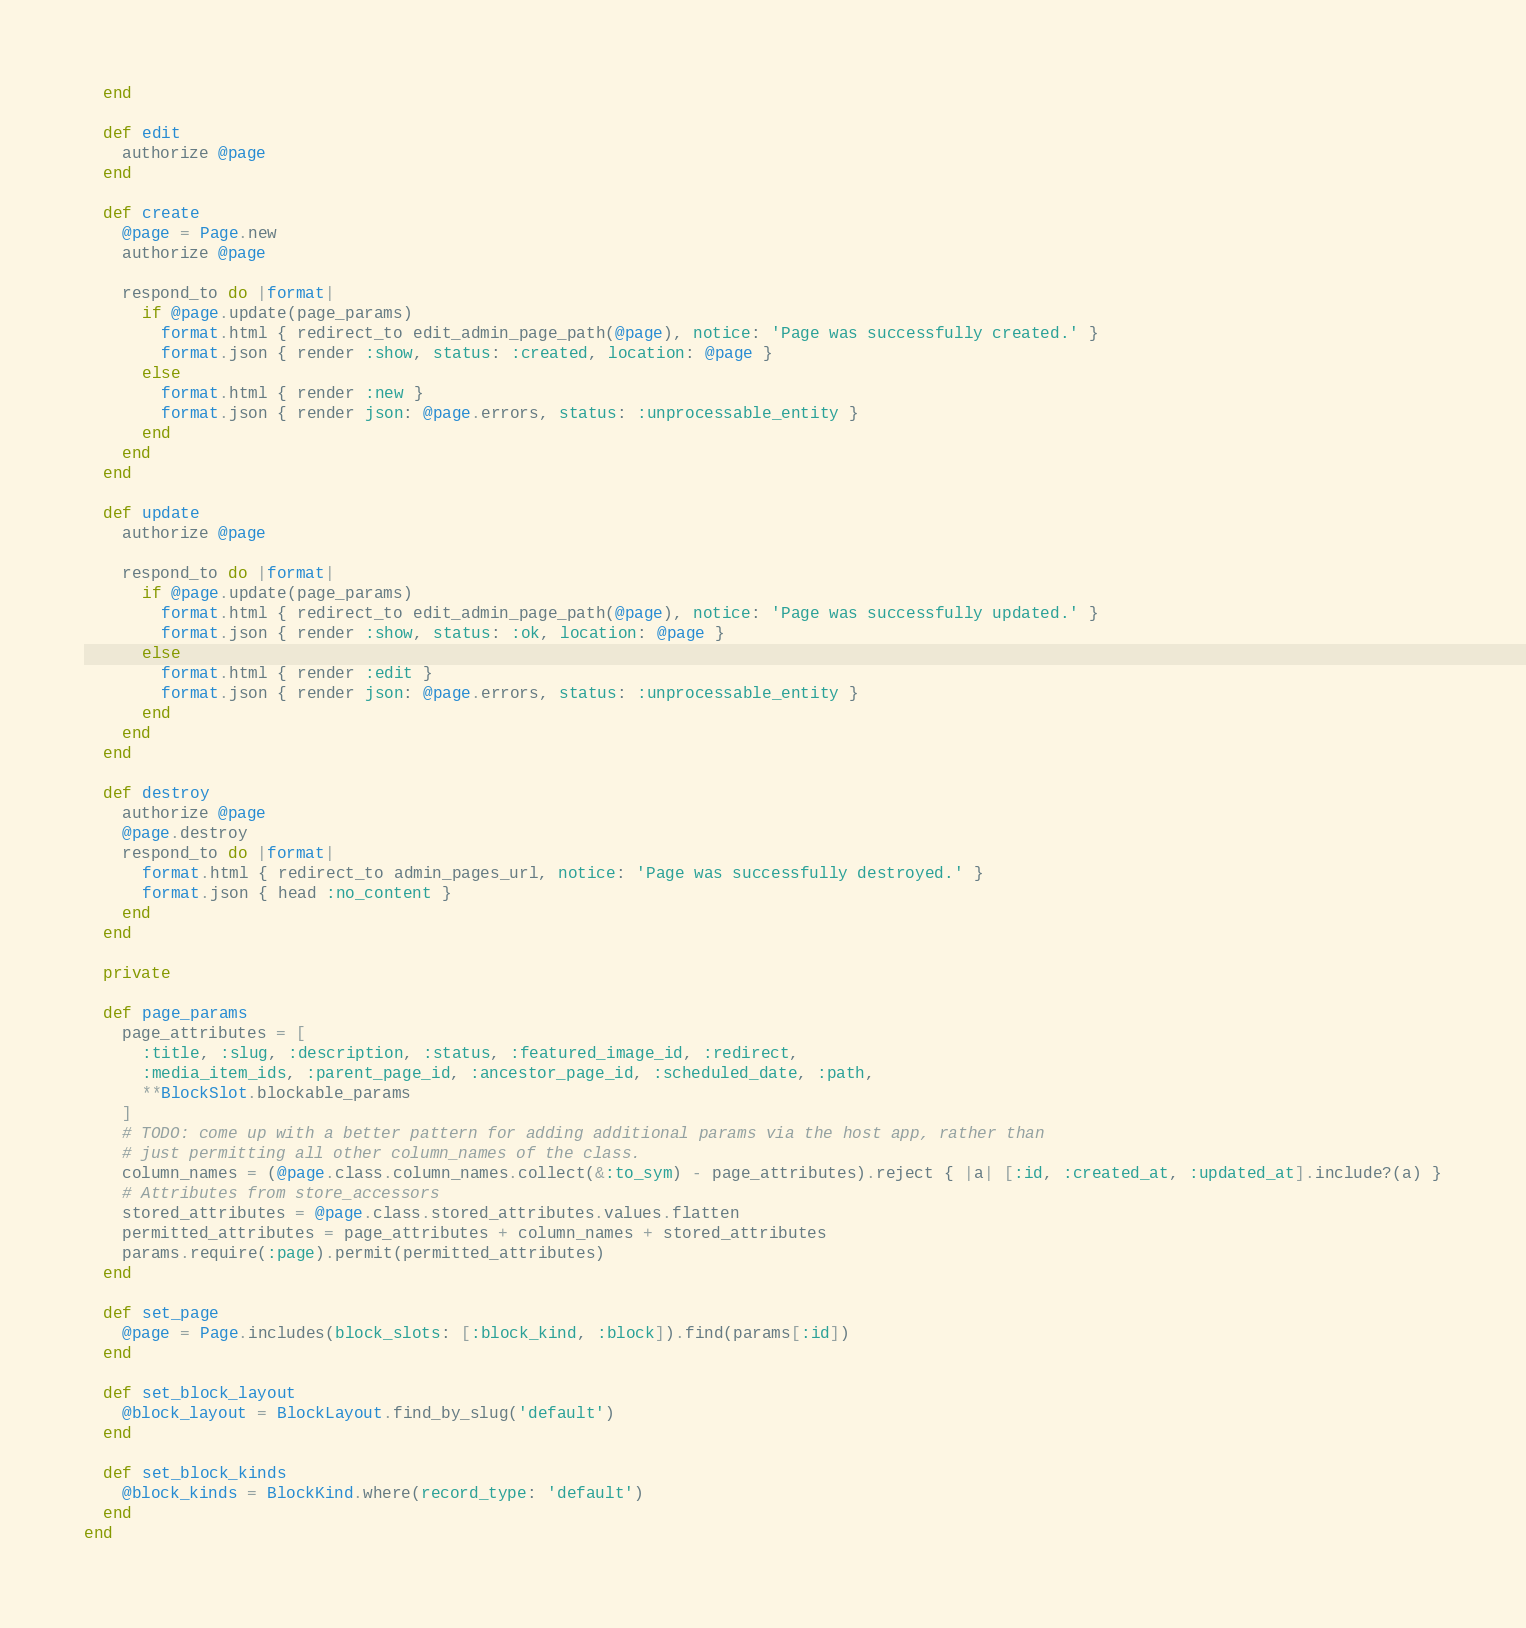<code> <loc_0><loc_0><loc_500><loc_500><_Ruby_>  end

  def edit
    authorize @page
  end

  def create
    @page = Page.new
    authorize @page

    respond_to do |format|
      if @page.update(page_params)
        format.html { redirect_to edit_admin_page_path(@page), notice: 'Page was successfully created.' }
        format.json { render :show, status: :created, location: @page }
      else
        format.html { render :new }
        format.json { render json: @page.errors, status: :unprocessable_entity }
      end
    end
  end

  def update
    authorize @page

    respond_to do |format|
      if @page.update(page_params)
        format.html { redirect_to edit_admin_page_path(@page), notice: 'Page was successfully updated.' }
        format.json { render :show, status: :ok, location: @page }
      else
        format.html { render :edit }
        format.json { render json: @page.errors, status: :unprocessable_entity }
      end
    end
  end

  def destroy
    authorize @page
    @page.destroy
    respond_to do |format|
      format.html { redirect_to admin_pages_url, notice: 'Page was successfully destroyed.' }
      format.json { head :no_content }
    end
  end

  private

  def page_params
    page_attributes = [
      :title, :slug, :description, :status, :featured_image_id, :redirect,
      :media_item_ids, :parent_page_id, :ancestor_page_id, :scheduled_date, :path,
      **BlockSlot.blockable_params
    ]
    # TODO: come up with a better pattern for adding additional params via the host app, rather than
    # just permitting all other column_names of the class.
    column_names = (@page.class.column_names.collect(&:to_sym) - page_attributes).reject { |a| [:id, :created_at, :updated_at].include?(a) }
    # Attributes from store_accessors
    stored_attributes = @page.class.stored_attributes.values.flatten
    permitted_attributes = page_attributes + column_names + stored_attributes
    params.require(:page).permit(permitted_attributes)
  end

  def set_page
    @page = Page.includes(block_slots: [:block_kind, :block]).find(params[:id])
  end

  def set_block_layout
    @block_layout = BlockLayout.find_by_slug('default')
  end

  def set_block_kinds
    @block_kinds = BlockKind.where(record_type: 'default')
  end
end
</code> 